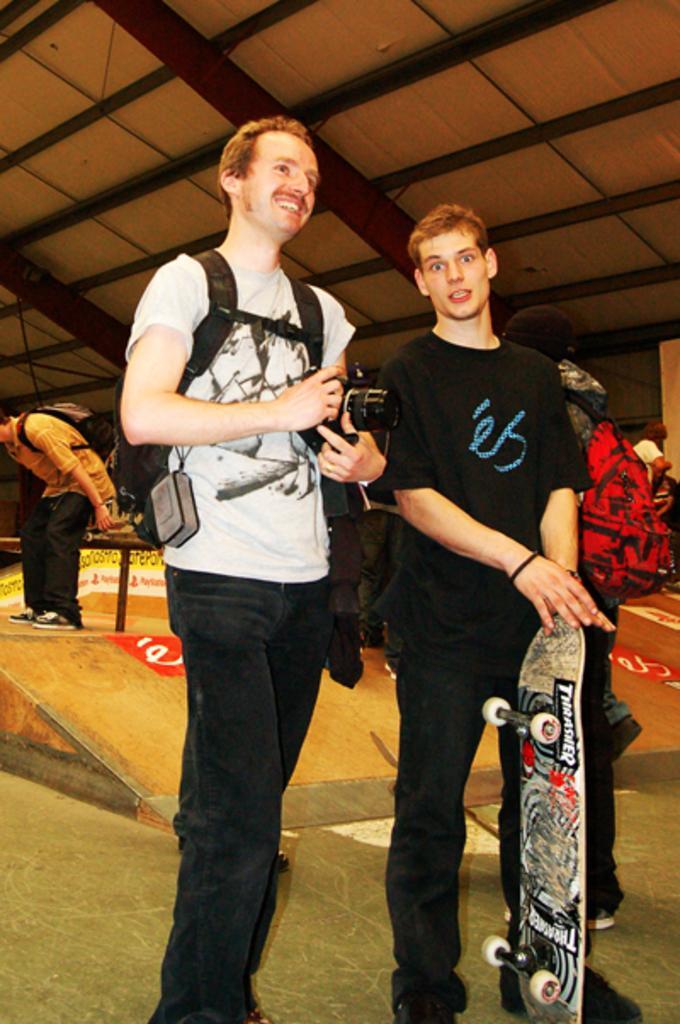Describe this image in one or two sentences. In this image we can see people standing on the floor of them one is holding camera in the hand and the other is holding skateboard in the hands. In the background we can see shed. 